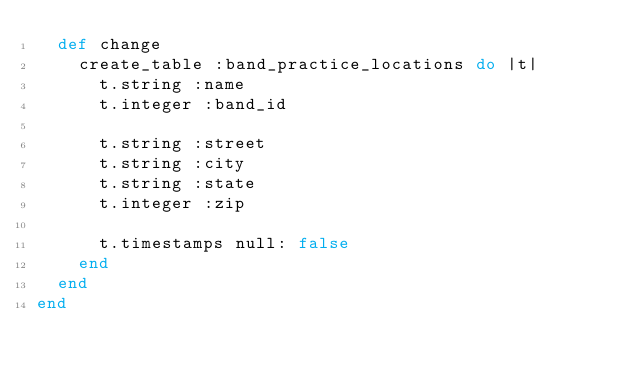<code> <loc_0><loc_0><loc_500><loc_500><_Ruby_>  def change
    create_table :band_practice_locations do |t|
      t.string :name
      t.integer :band_id

      t.string :street
      t.string :city
      t.string :state
      t.integer :zip

      t.timestamps null: false
    end
  end
end
</code> 